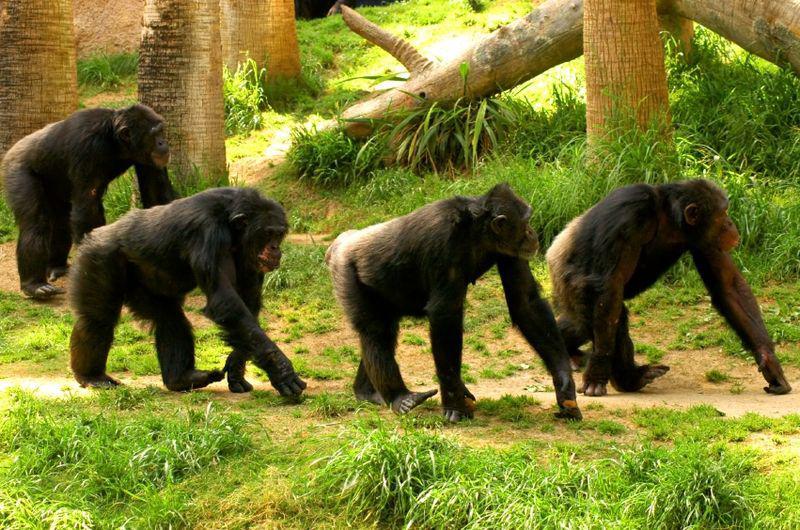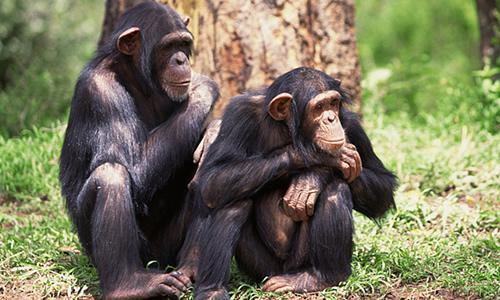The first image is the image on the left, the second image is the image on the right. Analyze the images presented: Is the assertion "There is a single hairless chimp in the right image." valid? Answer yes or no. No. The first image is the image on the left, the second image is the image on the right. For the images shown, is this caption "An image shows one squatting ape, which is hairless." true? Answer yes or no. No. 